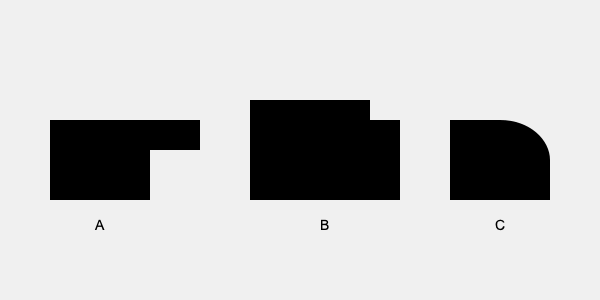Identify the emergency vehicles represented by the silhouettes A, B, and C. Which silhouette represents a fire truck? To identify the emergency vehicles and determine which silhouette represents a fire truck, let's analyze each silhouette:

1. Silhouette A:
   - Has a boxy shape with a distinctive stepped roof
   - The front is relatively short compared to the body
   - This shape is typical of an ambulance

2. Silhouette B:
   - Has a long, rectangular body
   - Features a distinctive high cab at the front
   - The overall length and height are greater than the other vehicles
   - This shape is characteristic of a fire truck

3. Silhouette C:
   - Has a more streamlined, car-like shape
   - Features a sloping front end and a distinct roof
   - This shape is typical of a police car

Based on these observations, we can conclude that silhouette B represents a fire truck.
Answer: B 